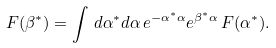<formula> <loc_0><loc_0><loc_500><loc_500>F ( \beta ^ { * } ) = \int \, d \alpha ^ { * } d \alpha \, e ^ { - \alpha ^ { * } \alpha } e ^ { \beta ^ { * } \alpha } \, F ( \alpha ^ { * } ) .</formula> 